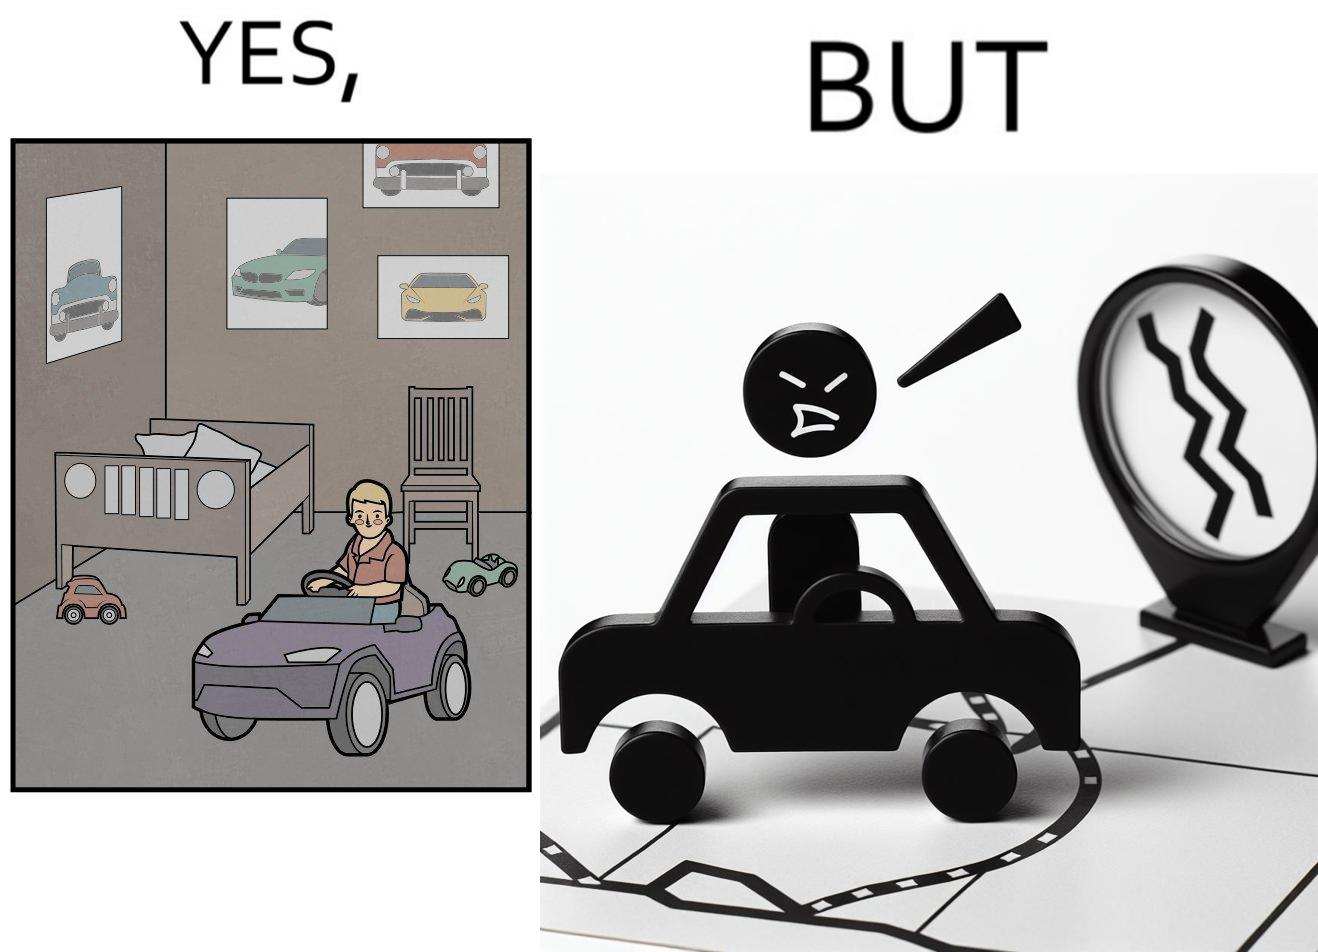What does this image depict? The image is funny beaucse while the person as a child enjoyed being around cars, had various small toy cars and even rode a bigger toy car, as as grown up he does not enjoy being in a car during a traffic jam while he is driving . 